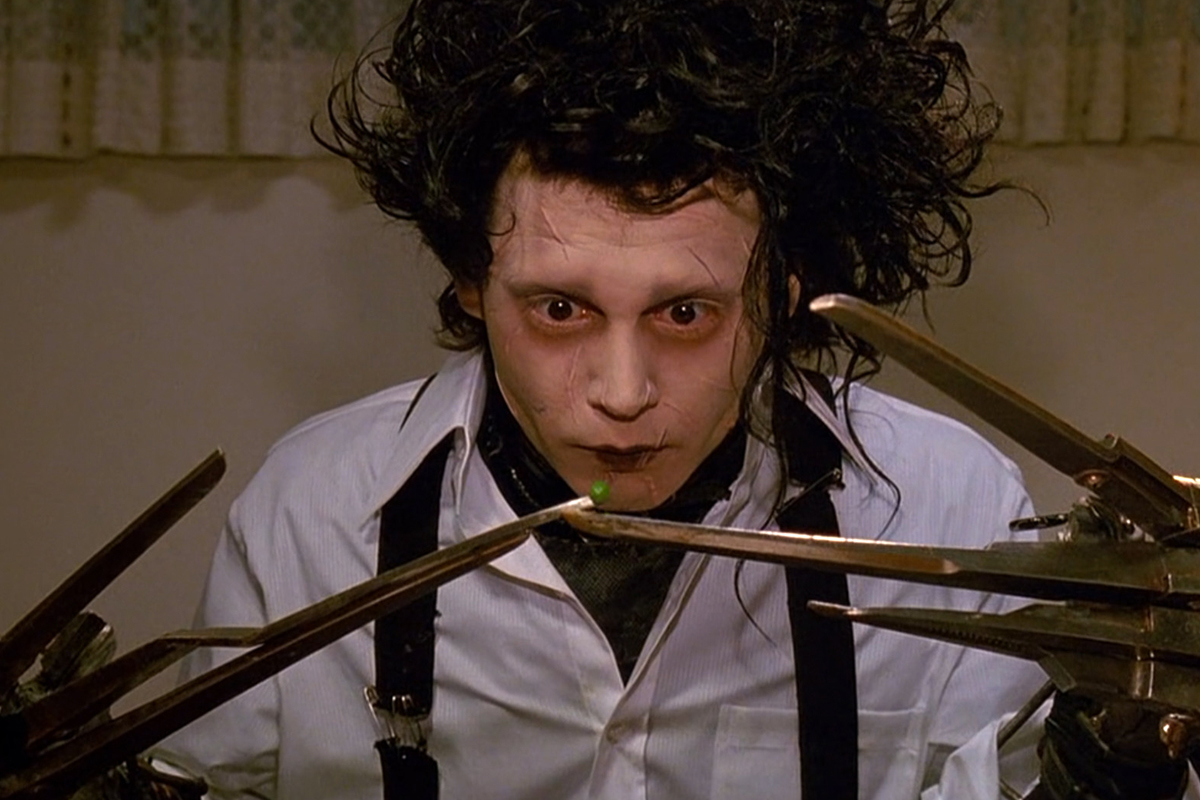What if Edward Scissorhands lived in a magical forest instead? Paint me a picture of that world. In a magical forest, Edward Scissorhands would find a realm that echoes the wonder of his own existence. Tall, ancient trees with whispering leaves and luminescent flowers would greet him, their beauty reflecting his intricate nature. The forest creatures, enchanted by his delicate touch and the creative sculptures he carves from the woods, would form a unique bond with him. Edward's scissor hands, seen as tools of magic rather than fear, would allow him to shape the forest into a mesmerizing art piece, where paths of glittering stones lead to fantastical figures carved into tree trunks. The magical forest, with its serene, ethereal ambiance, would be a sanctuary where Edward feels a deep connection to nature and discovers an eternal sense of belonging. 